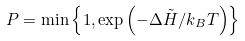Convert formula to latex. <formula><loc_0><loc_0><loc_500><loc_500>P = \min \left \{ 1 , \exp \left ( - \Delta \tilde { H } / k _ { B } T \right ) \right \}</formula> 